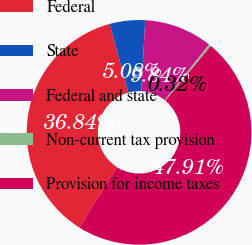<chart> <loc_0><loc_0><loc_500><loc_500><pie_chart><fcel>Federal<fcel>State<fcel>Federal and state<fcel>Non-current tax provision<fcel>Provision for income taxes<nl><fcel>36.84%<fcel>5.08%<fcel>9.84%<fcel>0.32%<fcel>47.91%<nl></chart> 